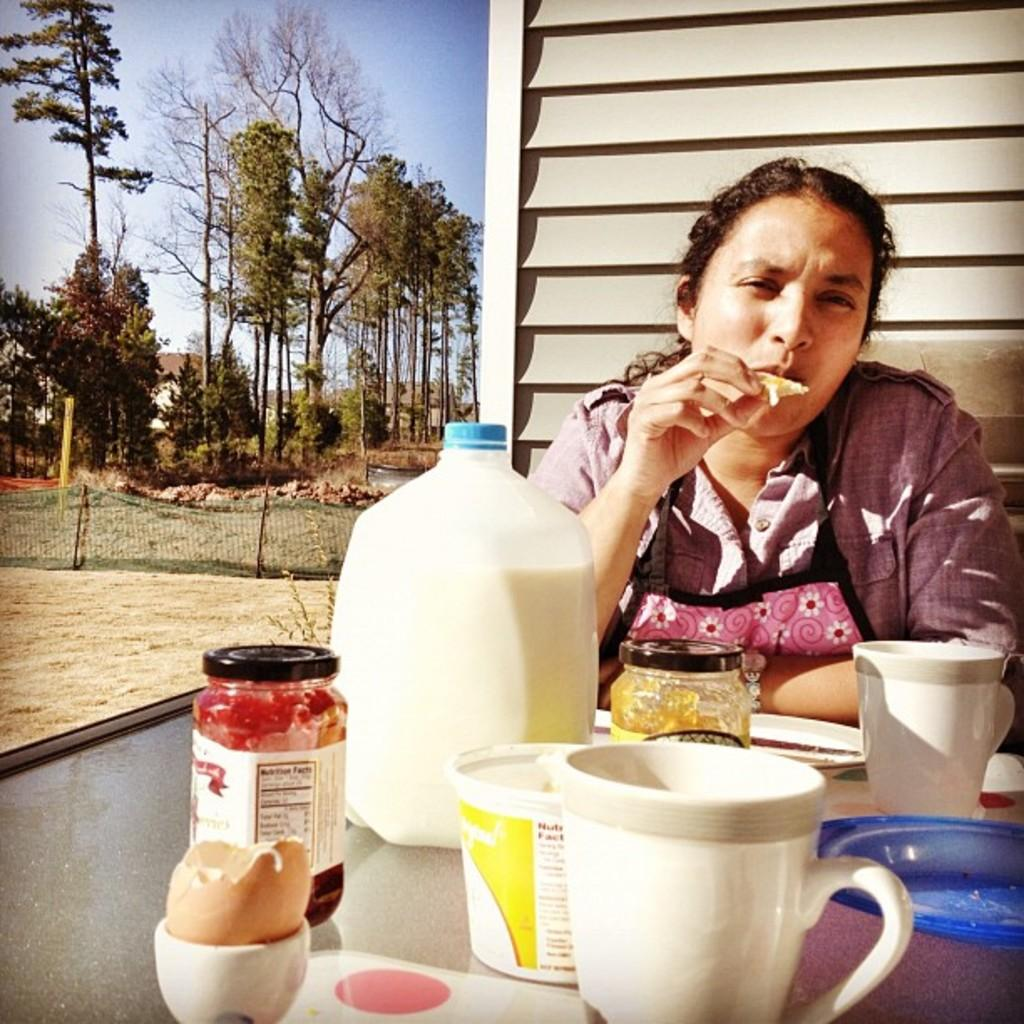What is the woman in the image doing? The woman is sitting and eating food in the image. What items are in front of the woman? There is a bottle, cups, a jar, and a plate in front of the woman. What can be seen on the table in the image? There are objects on the table in the image. What is visible in the background of the image? There is a net, trees, houses, and the sky visible in the background. How many cracks can be heard in the image? There are no cracks audible in the image, as it is a still image. 